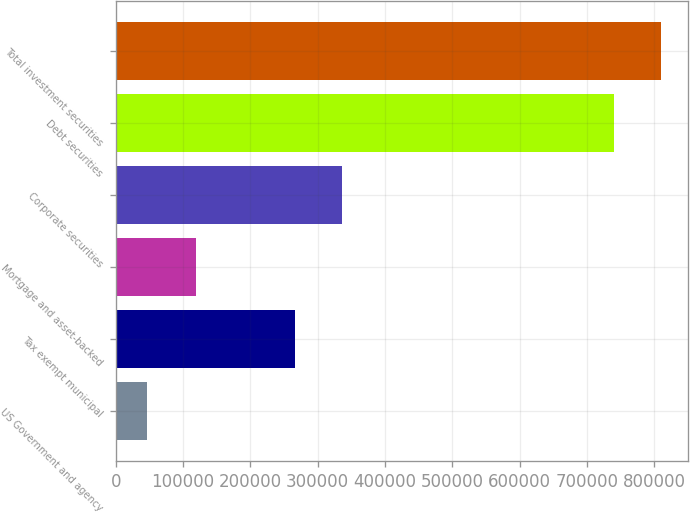<chart> <loc_0><loc_0><loc_500><loc_500><bar_chart><fcel>US Government and agency<fcel>Tax exempt municipal<fcel>Mortgage and asset-backed<fcel>Corporate securities<fcel>Debt securities<fcel>Total investment securities<nl><fcel>46272<fcel>265816<fcel>118474<fcel>335814<fcel>739846<fcel>809844<nl></chart> 